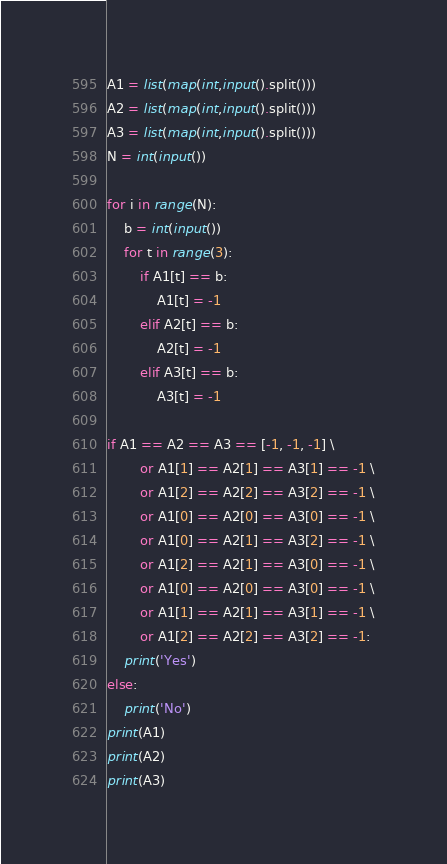<code> <loc_0><loc_0><loc_500><loc_500><_Python_>A1 = list(map(int,input().split()))
A2 = list(map(int,input().split()))
A3 = list(map(int,input().split()))
N = int(input())

for i in range(N):
    b = int(input())
    for t in range(3):
        if A1[t] == b:
            A1[t] = -1
        elif A2[t] == b:
            A2[t] = -1
        elif A3[t] == b:
            A3[t] = -1

if A1 == A2 == A3 == [-1, -1, -1] \
        or A1[1] == A2[1] == A3[1] == -1 \
        or A1[2] == A2[2] == A3[2] == -1 \
        or A1[0] == A2[0] == A3[0] == -1 \
        or A1[0] == A2[1] == A3[2] == -1 \
        or A1[2] == A2[1] == A3[0] == -1 \
        or A1[0] == A2[0] == A3[0] == -1 \
        or A1[1] == A2[1] == A3[1] == -1 \
        or A1[2] == A2[2] == A3[2] == -1:
    print('Yes')
else:
    print('No')
print(A1)
print(A2)
print(A3)</code> 